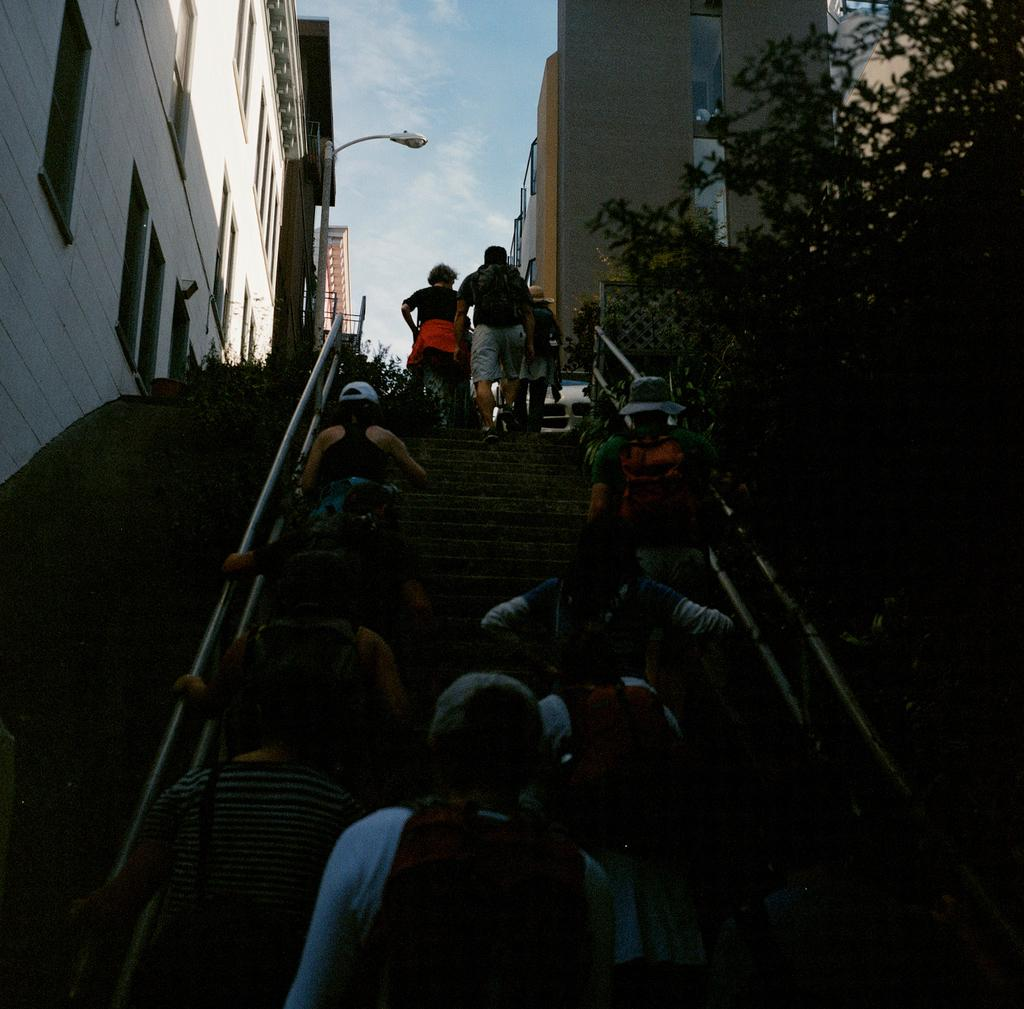How many people are in the image? There is a group of persons in the image. What are the persons in the image doing? The persons are walking through the stairs. What type of vegetation can be seen in the image? There are trees visible in the image. What structures can be seen on both sides of the image? There are houses on the left side and right side of the image. What type of bead is being used to decorate the road in the image? There is no road or bead present in the image; it features a group of persons walking through the stairs with trees and houses in the background. 